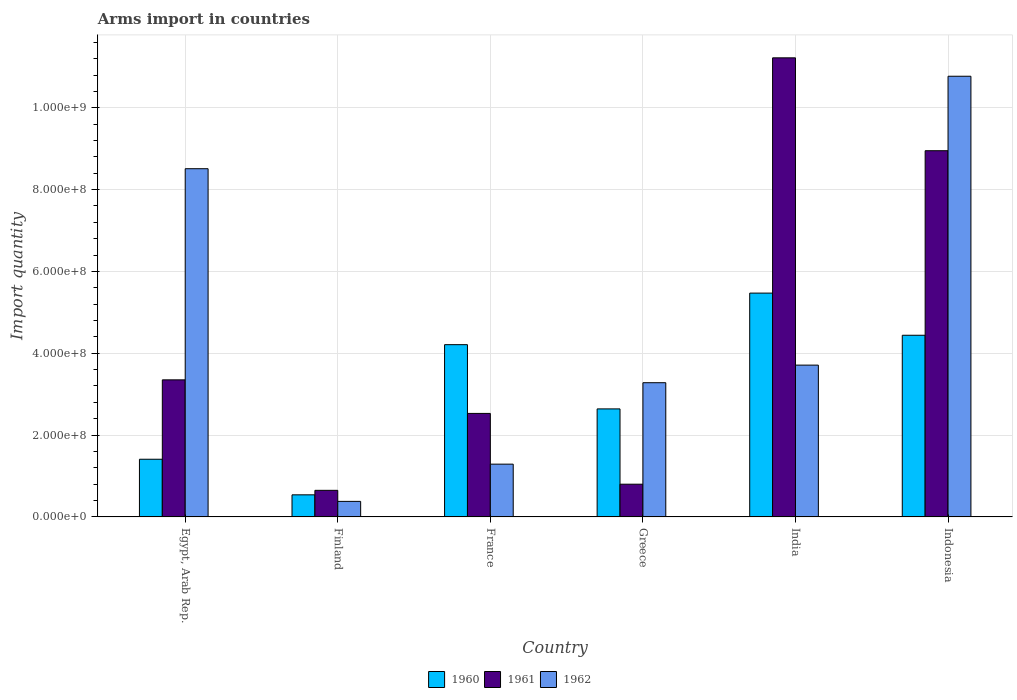How many different coloured bars are there?
Your response must be concise. 3. Are the number of bars per tick equal to the number of legend labels?
Offer a very short reply. Yes. Are the number of bars on each tick of the X-axis equal?
Offer a very short reply. Yes. In how many cases, is the number of bars for a given country not equal to the number of legend labels?
Your answer should be very brief. 0. What is the total arms import in 1962 in India?
Your response must be concise. 3.71e+08. Across all countries, what is the maximum total arms import in 1960?
Provide a succinct answer. 5.47e+08. Across all countries, what is the minimum total arms import in 1962?
Provide a short and direct response. 3.80e+07. In which country was the total arms import in 1961 maximum?
Offer a very short reply. India. What is the total total arms import in 1962 in the graph?
Your answer should be compact. 2.79e+09. What is the difference between the total arms import in 1960 in Finland and that in Indonesia?
Offer a very short reply. -3.90e+08. What is the difference between the total arms import in 1960 in Greece and the total arms import in 1962 in Indonesia?
Give a very brief answer. -8.13e+08. What is the average total arms import in 1961 per country?
Offer a terse response. 4.58e+08. What is the difference between the total arms import of/in 1961 and total arms import of/in 1960 in Greece?
Give a very brief answer. -1.84e+08. What is the ratio of the total arms import in 1962 in Finland to that in Indonesia?
Ensure brevity in your answer.  0.04. Is the difference between the total arms import in 1961 in Finland and France greater than the difference between the total arms import in 1960 in Finland and France?
Make the answer very short. Yes. What is the difference between the highest and the second highest total arms import in 1961?
Provide a short and direct response. 7.87e+08. What is the difference between the highest and the lowest total arms import in 1962?
Your answer should be very brief. 1.04e+09. What does the 2nd bar from the left in Egypt, Arab Rep. represents?
Ensure brevity in your answer.  1961. What does the 1st bar from the right in Finland represents?
Offer a very short reply. 1962. How many bars are there?
Give a very brief answer. 18. Are all the bars in the graph horizontal?
Offer a very short reply. No. What is the difference between two consecutive major ticks on the Y-axis?
Make the answer very short. 2.00e+08. Does the graph contain grids?
Ensure brevity in your answer.  Yes. Where does the legend appear in the graph?
Provide a short and direct response. Bottom center. How are the legend labels stacked?
Your response must be concise. Horizontal. What is the title of the graph?
Make the answer very short. Arms import in countries. What is the label or title of the X-axis?
Give a very brief answer. Country. What is the label or title of the Y-axis?
Give a very brief answer. Import quantity. What is the Import quantity in 1960 in Egypt, Arab Rep.?
Ensure brevity in your answer.  1.41e+08. What is the Import quantity in 1961 in Egypt, Arab Rep.?
Offer a terse response. 3.35e+08. What is the Import quantity of 1962 in Egypt, Arab Rep.?
Provide a short and direct response. 8.51e+08. What is the Import quantity of 1960 in Finland?
Keep it short and to the point. 5.40e+07. What is the Import quantity of 1961 in Finland?
Your answer should be very brief. 6.50e+07. What is the Import quantity in 1962 in Finland?
Provide a succinct answer. 3.80e+07. What is the Import quantity in 1960 in France?
Offer a very short reply. 4.21e+08. What is the Import quantity of 1961 in France?
Provide a short and direct response. 2.53e+08. What is the Import quantity of 1962 in France?
Your answer should be very brief. 1.29e+08. What is the Import quantity in 1960 in Greece?
Make the answer very short. 2.64e+08. What is the Import quantity in 1961 in Greece?
Your answer should be very brief. 8.00e+07. What is the Import quantity of 1962 in Greece?
Keep it short and to the point. 3.28e+08. What is the Import quantity in 1960 in India?
Keep it short and to the point. 5.47e+08. What is the Import quantity in 1961 in India?
Your answer should be very brief. 1.12e+09. What is the Import quantity of 1962 in India?
Your answer should be compact. 3.71e+08. What is the Import quantity in 1960 in Indonesia?
Your answer should be compact. 4.44e+08. What is the Import quantity of 1961 in Indonesia?
Offer a terse response. 8.95e+08. What is the Import quantity of 1962 in Indonesia?
Make the answer very short. 1.08e+09. Across all countries, what is the maximum Import quantity of 1960?
Keep it short and to the point. 5.47e+08. Across all countries, what is the maximum Import quantity of 1961?
Provide a short and direct response. 1.12e+09. Across all countries, what is the maximum Import quantity of 1962?
Ensure brevity in your answer.  1.08e+09. Across all countries, what is the minimum Import quantity of 1960?
Give a very brief answer. 5.40e+07. Across all countries, what is the minimum Import quantity of 1961?
Offer a very short reply. 6.50e+07. Across all countries, what is the minimum Import quantity of 1962?
Provide a short and direct response. 3.80e+07. What is the total Import quantity of 1960 in the graph?
Your response must be concise. 1.87e+09. What is the total Import quantity in 1961 in the graph?
Your answer should be compact. 2.75e+09. What is the total Import quantity in 1962 in the graph?
Offer a terse response. 2.79e+09. What is the difference between the Import quantity of 1960 in Egypt, Arab Rep. and that in Finland?
Make the answer very short. 8.70e+07. What is the difference between the Import quantity of 1961 in Egypt, Arab Rep. and that in Finland?
Your answer should be very brief. 2.70e+08. What is the difference between the Import quantity of 1962 in Egypt, Arab Rep. and that in Finland?
Your answer should be compact. 8.13e+08. What is the difference between the Import quantity of 1960 in Egypt, Arab Rep. and that in France?
Make the answer very short. -2.80e+08. What is the difference between the Import quantity in 1961 in Egypt, Arab Rep. and that in France?
Your response must be concise. 8.20e+07. What is the difference between the Import quantity of 1962 in Egypt, Arab Rep. and that in France?
Your answer should be compact. 7.22e+08. What is the difference between the Import quantity in 1960 in Egypt, Arab Rep. and that in Greece?
Give a very brief answer. -1.23e+08. What is the difference between the Import quantity of 1961 in Egypt, Arab Rep. and that in Greece?
Keep it short and to the point. 2.55e+08. What is the difference between the Import quantity of 1962 in Egypt, Arab Rep. and that in Greece?
Your answer should be very brief. 5.23e+08. What is the difference between the Import quantity of 1960 in Egypt, Arab Rep. and that in India?
Keep it short and to the point. -4.06e+08. What is the difference between the Import quantity in 1961 in Egypt, Arab Rep. and that in India?
Provide a succinct answer. -7.87e+08. What is the difference between the Import quantity in 1962 in Egypt, Arab Rep. and that in India?
Keep it short and to the point. 4.80e+08. What is the difference between the Import quantity in 1960 in Egypt, Arab Rep. and that in Indonesia?
Your answer should be very brief. -3.03e+08. What is the difference between the Import quantity of 1961 in Egypt, Arab Rep. and that in Indonesia?
Offer a very short reply. -5.60e+08. What is the difference between the Import quantity in 1962 in Egypt, Arab Rep. and that in Indonesia?
Ensure brevity in your answer.  -2.26e+08. What is the difference between the Import quantity of 1960 in Finland and that in France?
Give a very brief answer. -3.67e+08. What is the difference between the Import quantity of 1961 in Finland and that in France?
Your response must be concise. -1.88e+08. What is the difference between the Import quantity of 1962 in Finland and that in France?
Provide a succinct answer. -9.10e+07. What is the difference between the Import quantity of 1960 in Finland and that in Greece?
Make the answer very short. -2.10e+08. What is the difference between the Import quantity in 1961 in Finland and that in Greece?
Make the answer very short. -1.50e+07. What is the difference between the Import quantity in 1962 in Finland and that in Greece?
Give a very brief answer. -2.90e+08. What is the difference between the Import quantity in 1960 in Finland and that in India?
Make the answer very short. -4.93e+08. What is the difference between the Import quantity of 1961 in Finland and that in India?
Provide a short and direct response. -1.06e+09. What is the difference between the Import quantity in 1962 in Finland and that in India?
Ensure brevity in your answer.  -3.33e+08. What is the difference between the Import quantity in 1960 in Finland and that in Indonesia?
Keep it short and to the point. -3.90e+08. What is the difference between the Import quantity of 1961 in Finland and that in Indonesia?
Ensure brevity in your answer.  -8.30e+08. What is the difference between the Import quantity of 1962 in Finland and that in Indonesia?
Your answer should be compact. -1.04e+09. What is the difference between the Import quantity of 1960 in France and that in Greece?
Offer a very short reply. 1.57e+08. What is the difference between the Import quantity of 1961 in France and that in Greece?
Your response must be concise. 1.73e+08. What is the difference between the Import quantity in 1962 in France and that in Greece?
Offer a very short reply. -1.99e+08. What is the difference between the Import quantity of 1960 in France and that in India?
Give a very brief answer. -1.26e+08. What is the difference between the Import quantity of 1961 in France and that in India?
Provide a succinct answer. -8.69e+08. What is the difference between the Import quantity in 1962 in France and that in India?
Give a very brief answer. -2.42e+08. What is the difference between the Import quantity in 1960 in France and that in Indonesia?
Offer a very short reply. -2.30e+07. What is the difference between the Import quantity of 1961 in France and that in Indonesia?
Provide a succinct answer. -6.42e+08. What is the difference between the Import quantity in 1962 in France and that in Indonesia?
Offer a very short reply. -9.48e+08. What is the difference between the Import quantity in 1960 in Greece and that in India?
Ensure brevity in your answer.  -2.83e+08. What is the difference between the Import quantity in 1961 in Greece and that in India?
Your answer should be compact. -1.04e+09. What is the difference between the Import quantity in 1962 in Greece and that in India?
Provide a succinct answer. -4.30e+07. What is the difference between the Import quantity in 1960 in Greece and that in Indonesia?
Give a very brief answer. -1.80e+08. What is the difference between the Import quantity in 1961 in Greece and that in Indonesia?
Give a very brief answer. -8.15e+08. What is the difference between the Import quantity in 1962 in Greece and that in Indonesia?
Keep it short and to the point. -7.49e+08. What is the difference between the Import quantity of 1960 in India and that in Indonesia?
Provide a succinct answer. 1.03e+08. What is the difference between the Import quantity in 1961 in India and that in Indonesia?
Offer a terse response. 2.27e+08. What is the difference between the Import quantity of 1962 in India and that in Indonesia?
Provide a short and direct response. -7.06e+08. What is the difference between the Import quantity of 1960 in Egypt, Arab Rep. and the Import quantity of 1961 in Finland?
Offer a very short reply. 7.60e+07. What is the difference between the Import quantity in 1960 in Egypt, Arab Rep. and the Import quantity in 1962 in Finland?
Your answer should be very brief. 1.03e+08. What is the difference between the Import quantity of 1961 in Egypt, Arab Rep. and the Import quantity of 1962 in Finland?
Make the answer very short. 2.97e+08. What is the difference between the Import quantity of 1960 in Egypt, Arab Rep. and the Import quantity of 1961 in France?
Your response must be concise. -1.12e+08. What is the difference between the Import quantity of 1961 in Egypt, Arab Rep. and the Import quantity of 1962 in France?
Provide a short and direct response. 2.06e+08. What is the difference between the Import quantity in 1960 in Egypt, Arab Rep. and the Import quantity in 1961 in Greece?
Your response must be concise. 6.10e+07. What is the difference between the Import quantity in 1960 in Egypt, Arab Rep. and the Import quantity in 1962 in Greece?
Offer a terse response. -1.87e+08. What is the difference between the Import quantity in 1960 in Egypt, Arab Rep. and the Import quantity in 1961 in India?
Offer a terse response. -9.81e+08. What is the difference between the Import quantity of 1960 in Egypt, Arab Rep. and the Import quantity of 1962 in India?
Provide a succinct answer. -2.30e+08. What is the difference between the Import quantity of 1961 in Egypt, Arab Rep. and the Import quantity of 1962 in India?
Provide a short and direct response. -3.60e+07. What is the difference between the Import quantity in 1960 in Egypt, Arab Rep. and the Import quantity in 1961 in Indonesia?
Provide a succinct answer. -7.54e+08. What is the difference between the Import quantity in 1960 in Egypt, Arab Rep. and the Import quantity in 1962 in Indonesia?
Give a very brief answer. -9.36e+08. What is the difference between the Import quantity in 1961 in Egypt, Arab Rep. and the Import quantity in 1962 in Indonesia?
Provide a succinct answer. -7.42e+08. What is the difference between the Import quantity in 1960 in Finland and the Import quantity in 1961 in France?
Offer a terse response. -1.99e+08. What is the difference between the Import quantity of 1960 in Finland and the Import quantity of 1962 in France?
Give a very brief answer. -7.50e+07. What is the difference between the Import quantity in 1961 in Finland and the Import quantity in 1962 in France?
Your answer should be very brief. -6.40e+07. What is the difference between the Import quantity in 1960 in Finland and the Import quantity in 1961 in Greece?
Your answer should be very brief. -2.60e+07. What is the difference between the Import quantity in 1960 in Finland and the Import quantity in 1962 in Greece?
Ensure brevity in your answer.  -2.74e+08. What is the difference between the Import quantity in 1961 in Finland and the Import quantity in 1962 in Greece?
Provide a short and direct response. -2.63e+08. What is the difference between the Import quantity of 1960 in Finland and the Import quantity of 1961 in India?
Provide a short and direct response. -1.07e+09. What is the difference between the Import quantity in 1960 in Finland and the Import quantity in 1962 in India?
Ensure brevity in your answer.  -3.17e+08. What is the difference between the Import quantity of 1961 in Finland and the Import quantity of 1962 in India?
Keep it short and to the point. -3.06e+08. What is the difference between the Import quantity in 1960 in Finland and the Import quantity in 1961 in Indonesia?
Offer a terse response. -8.41e+08. What is the difference between the Import quantity in 1960 in Finland and the Import quantity in 1962 in Indonesia?
Offer a very short reply. -1.02e+09. What is the difference between the Import quantity in 1961 in Finland and the Import quantity in 1962 in Indonesia?
Offer a very short reply. -1.01e+09. What is the difference between the Import quantity of 1960 in France and the Import quantity of 1961 in Greece?
Your response must be concise. 3.41e+08. What is the difference between the Import quantity of 1960 in France and the Import quantity of 1962 in Greece?
Your response must be concise. 9.30e+07. What is the difference between the Import quantity in 1961 in France and the Import quantity in 1962 in Greece?
Make the answer very short. -7.50e+07. What is the difference between the Import quantity of 1960 in France and the Import quantity of 1961 in India?
Provide a succinct answer. -7.01e+08. What is the difference between the Import quantity of 1961 in France and the Import quantity of 1962 in India?
Your response must be concise. -1.18e+08. What is the difference between the Import quantity of 1960 in France and the Import quantity of 1961 in Indonesia?
Offer a very short reply. -4.74e+08. What is the difference between the Import quantity of 1960 in France and the Import quantity of 1962 in Indonesia?
Provide a succinct answer. -6.56e+08. What is the difference between the Import quantity of 1961 in France and the Import quantity of 1962 in Indonesia?
Offer a terse response. -8.24e+08. What is the difference between the Import quantity of 1960 in Greece and the Import quantity of 1961 in India?
Offer a very short reply. -8.58e+08. What is the difference between the Import quantity of 1960 in Greece and the Import quantity of 1962 in India?
Ensure brevity in your answer.  -1.07e+08. What is the difference between the Import quantity in 1961 in Greece and the Import quantity in 1962 in India?
Make the answer very short. -2.91e+08. What is the difference between the Import quantity of 1960 in Greece and the Import quantity of 1961 in Indonesia?
Offer a terse response. -6.31e+08. What is the difference between the Import quantity of 1960 in Greece and the Import quantity of 1962 in Indonesia?
Offer a very short reply. -8.13e+08. What is the difference between the Import quantity of 1961 in Greece and the Import quantity of 1962 in Indonesia?
Provide a succinct answer. -9.97e+08. What is the difference between the Import quantity in 1960 in India and the Import quantity in 1961 in Indonesia?
Offer a very short reply. -3.48e+08. What is the difference between the Import quantity of 1960 in India and the Import quantity of 1962 in Indonesia?
Ensure brevity in your answer.  -5.30e+08. What is the difference between the Import quantity in 1961 in India and the Import quantity in 1962 in Indonesia?
Your answer should be compact. 4.50e+07. What is the average Import quantity in 1960 per country?
Offer a terse response. 3.12e+08. What is the average Import quantity of 1961 per country?
Your answer should be compact. 4.58e+08. What is the average Import quantity in 1962 per country?
Provide a succinct answer. 4.66e+08. What is the difference between the Import quantity of 1960 and Import quantity of 1961 in Egypt, Arab Rep.?
Make the answer very short. -1.94e+08. What is the difference between the Import quantity of 1960 and Import quantity of 1962 in Egypt, Arab Rep.?
Provide a succinct answer. -7.10e+08. What is the difference between the Import quantity of 1961 and Import quantity of 1962 in Egypt, Arab Rep.?
Make the answer very short. -5.16e+08. What is the difference between the Import quantity in 1960 and Import quantity in 1961 in Finland?
Ensure brevity in your answer.  -1.10e+07. What is the difference between the Import quantity in 1960 and Import quantity in 1962 in Finland?
Your answer should be very brief. 1.60e+07. What is the difference between the Import quantity in 1961 and Import quantity in 1962 in Finland?
Offer a very short reply. 2.70e+07. What is the difference between the Import quantity of 1960 and Import quantity of 1961 in France?
Ensure brevity in your answer.  1.68e+08. What is the difference between the Import quantity in 1960 and Import quantity in 1962 in France?
Keep it short and to the point. 2.92e+08. What is the difference between the Import quantity in 1961 and Import quantity in 1962 in France?
Keep it short and to the point. 1.24e+08. What is the difference between the Import quantity of 1960 and Import quantity of 1961 in Greece?
Provide a succinct answer. 1.84e+08. What is the difference between the Import quantity in 1960 and Import quantity in 1962 in Greece?
Offer a terse response. -6.40e+07. What is the difference between the Import quantity of 1961 and Import quantity of 1962 in Greece?
Provide a short and direct response. -2.48e+08. What is the difference between the Import quantity in 1960 and Import quantity in 1961 in India?
Provide a short and direct response. -5.75e+08. What is the difference between the Import quantity of 1960 and Import quantity of 1962 in India?
Your answer should be very brief. 1.76e+08. What is the difference between the Import quantity of 1961 and Import quantity of 1962 in India?
Offer a very short reply. 7.51e+08. What is the difference between the Import quantity of 1960 and Import quantity of 1961 in Indonesia?
Give a very brief answer. -4.51e+08. What is the difference between the Import quantity in 1960 and Import quantity in 1962 in Indonesia?
Your answer should be compact. -6.33e+08. What is the difference between the Import quantity in 1961 and Import quantity in 1962 in Indonesia?
Your response must be concise. -1.82e+08. What is the ratio of the Import quantity of 1960 in Egypt, Arab Rep. to that in Finland?
Offer a terse response. 2.61. What is the ratio of the Import quantity in 1961 in Egypt, Arab Rep. to that in Finland?
Give a very brief answer. 5.15. What is the ratio of the Import quantity of 1962 in Egypt, Arab Rep. to that in Finland?
Ensure brevity in your answer.  22.39. What is the ratio of the Import quantity of 1960 in Egypt, Arab Rep. to that in France?
Provide a short and direct response. 0.33. What is the ratio of the Import quantity of 1961 in Egypt, Arab Rep. to that in France?
Offer a very short reply. 1.32. What is the ratio of the Import quantity in 1962 in Egypt, Arab Rep. to that in France?
Ensure brevity in your answer.  6.6. What is the ratio of the Import quantity of 1960 in Egypt, Arab Rep. to that in Greece?
Your response must be concise. 0.53. What is the ratio of the Import quantity of 1961 in Egypt, Arab Rep. to that in Greece?
Provide a short and direct response. 4.19. What is the ratio of the Import quantity in 1962 in Egypt, Arab Rep. to that in Greece?
Provide a succinct answer. 2.59. What is the ratio of the Import quantity in 1960 in Egypt, Arab Rep. to that in India?
Your answer should be very brief. 0.26. What is the ratio of the Import quantity of 1961 in Egypt, Arab Rep. to that in India?
Make the answer very short. 0.3. What is the ratio of the Import quantity of 1962 in Egypt, Arab Rep. to that in India?
Offer a terse response. 2.29. What is the ratio of the Import quantity in 1960 in Egypt, Arab Rep. to that in Indonesia?
Keep it short and to the point. 0.32. What is the ratio of the Import quantity in 1961 in Egypt, Arab Rep. to that in Indonesia?
Your answer should be compact. 0.37. What is the ratio of the Import quantity of 1962 in Egypt, Arab Rep. to that in Indonesia?
Make the answer very short. 0.79. What is the ratio of the Import quantity in 1960 in Finland to that in France?
Offer a terse response. 0.13. What is the ratio of the Import quantity of 1961 in Finland to that in France?
Give a very brief answer. 0.26. What is the ratio of the Import quantity of 1962 in Finland to that in France?
Provide a short and direct response. 0.29. What is the ratio of the Import quantity in 1960 in Finland to that in Greece?
Your answer should be very brief. 0.2. What is the ratio of the Import quantity of 1961 in Finland to that in Greece?
Make the answer very short. 0.81. What is the ratio of the Import quantity of 1962 in Finland to that in Greece?
Give a very brief answer. 0.12. What is the ratio of the Import quantity of 1960 in Finland to that in India?
Make the answer very short. 0.1. What is the ratio of the Import quantity in 1961 in Finland to that in India?
Your answer should be very brief. 0.06. What is the ratio of the Import quantity in 1962 in Finland to that in India?
Ensure brevity in your answer.  0.1. What is the ratio of the Import quantity in 1960 in Finland to that in Indonesia?
Make the answer very short. 0.12. What is the ratio of the Import quantity of 1961 in Finland to that in Indonesia?
Provide a short and direct response. 0.07. What is the ratio of the Import quantity in 1962 in Finland to that in Indonesia?
Keep it short and to the point. 0.04. What is the ratio of the Import quantity of 1960 in France to that in Greece?
Offer a very short reply. 1.59. What is the ratio of the Import quantity in 1961 in France to that in Greece?
Ensure brevity in your answer.  3.16. What is the ratio of the Import quantity in 1962 in France to that in Greece?
Your answer should be compact. 0.39. What is the ratio of the Import quantity of 1960 in France to that in India?
Make the answer very short. 0.77. What is the ratio of the Import quantity of 1961 in France to that in India?
Provide a short and direct response. 0.23. What is the ratio of the Import quantity of 1962 in France to that in India?
Ensure brevity in your answer.  0.35. What is the ratio of the Import quantity of 1960 in France to that in Indonesia?
Your answer should be very brief. 0.95. What is the ratio of the Import quantity of 1961 in France to that in Indonesia?
Keep it short and to the point. 0.28. What is the ratio of the Import quantity of 1962 in France to that in Indonesia?
Offer a very short reply. 0.12. What is the ratio of the Import quantity in 1960 in Greece to that in India?
Offer a very short reply. 0.48. What is the ratio of the Import quantity in 1961 in Greece to that in India?
Make the answer very short. 0.07. What is the ratio of the Import quantity in 1962 in Greece to that in India?
Ensure brevity in your answer.  0.88. What is the ratio of the Import quantity of 1960 in Greece to that in Indonesia?
Make the answer very short. 0.59. What is the ratio of the Import quantity in 1961 in Greece to that in Indonesia?
Give a very brief answer. 0.09. What is the ratio of the Import quantity in 1962 in Greece to that in Indonesia?
Provide a short and direct response. 0.3. What is the ratio of the Import quantity in 1960 in India to that in Indonesia?
Ensure brevity in your answer.  1.23. What is the ratio of the Import quantity of 1961 in India to that in Indonesia?
Your answer should be very brief. 1.25. What is the ratio of the Import quantity in 1962 in India to that in Indonesia?
Your answer should be very brief. 0.34. What is the difference between the highest and the second highest Import quantity in 1960?
Offer a very short reply. 1.03e+08. What is the difference between the highest and the second highest Import quantity in 1961?
Ensure brevity in your answer.  2.27e+08. What is the difference between the highest and the second highest Import quantity of 1962?
Keep it short and to the point. 2.26e+08. What is the difference between the highest and the lowest Import quantity in 1960?
Your response must be concise. 4.93e+08. What is the difference between the highest and the lowest Import quantity of 1961?
Offer a very short reply. 1.06e+09. What is the difference between the highest and the lowest Import quantity of 1962?
Offer a very short reply. 1.04e+09. 